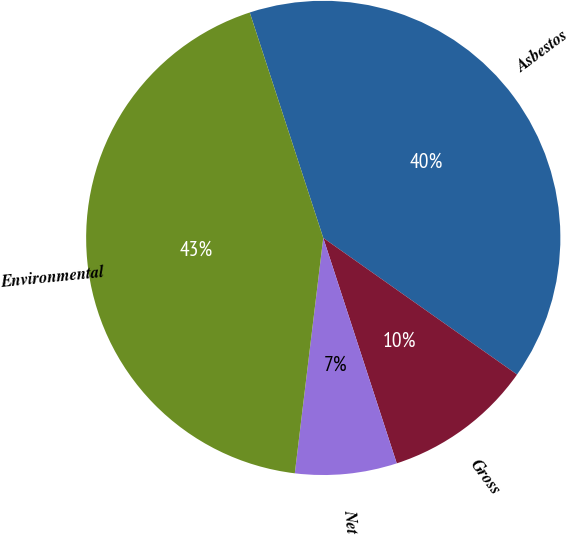Convert chart. <chart><loc_0><loc_0><loc_500><loc_500><pie_chart><fcel>Asbestos<fcel>Gross<fcel>Net<fcel>Environmental<nl><fcel>39.79%<fcel>10.21%<fcel>6.93%<fcel>43.07%<nl></chart> 